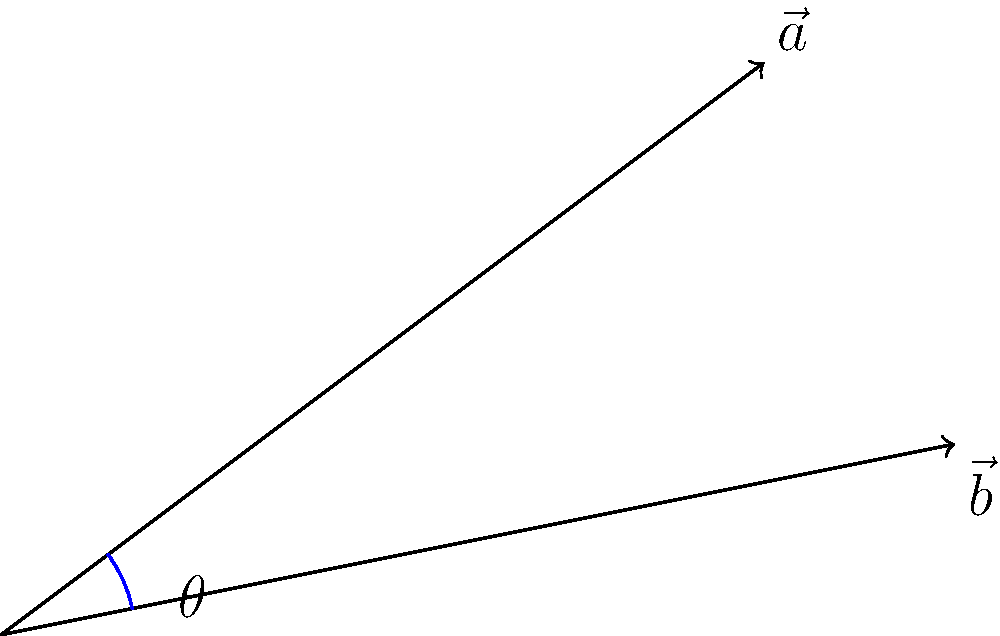Two loan repayment trajectories are represented by vectors $\vec{a} = (4, 3)$ and $\vec{b} = (5, 1)$. Calculate the angle $\theta$ between these two vectors to the nearest degree. This angle represents the divergence in your repayment strategies. A smaller angle indicates more similar approaches, while a larger angle suggests significantly different repayment methods. To find the angle between two vectors, we can use the dot product formula:

$$\cos \theta = \frac{\vec{a} \cdot \vec{b}}{|\vec{a}||\vec{b}|}$$

Step 1: Calculate the dot product $\vec{a} \cdot \vec{b}$
$$\vec{a} \cdot \vec{b} = (4 \times 5) + (3 \times 1) = 20 + 3 = 23$$

Step 2: Calculate the magnitudes of $\vec{a}$ and $\vec{b}$
$$|\vec{a}| = \sqrt{4^2 + 3^2} = \sqrt{16 + 9} = \sqrt{25} = 5$$
$$|\vec{b}| = \sqrt{5^2 + 1^2} = \sqrt{25 + 1} = \sqrt{26}$$

Step 3: Substitute into the formula
$$\cos \theta = \frac{23}{5\sqrt{26}}$$

Step 4: Take the inverse cosine (arccos) of both sides
$$\theta = \arccos(\frac{23}{5\sqrt{26}})$$

Step 5: Calculate the result and round to the nearest degree
$$\theta \approx 22.6°$$

Rounded to the nearest degree, $\theta = 23°$.
Answer: 23° 